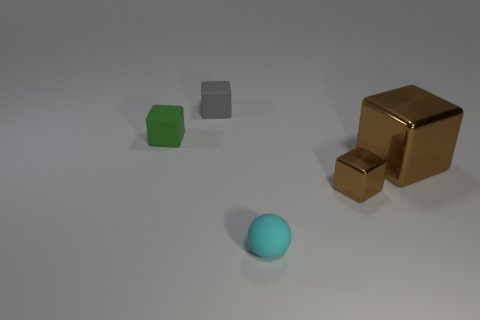Subtract all balls. How many objects are left? 4 Add 3 small gray cylinders. How many objects exist? 8 Subtract all cyan balls. Subtract all large red rubber cylinders. How many objects are left? 4 Add 2 balls. How many balls are left? 3 Add 3 tiny brown cubes. How many tiny brown cubes exist? 4 Subtract 0 red balls. How many objects are left? 5 